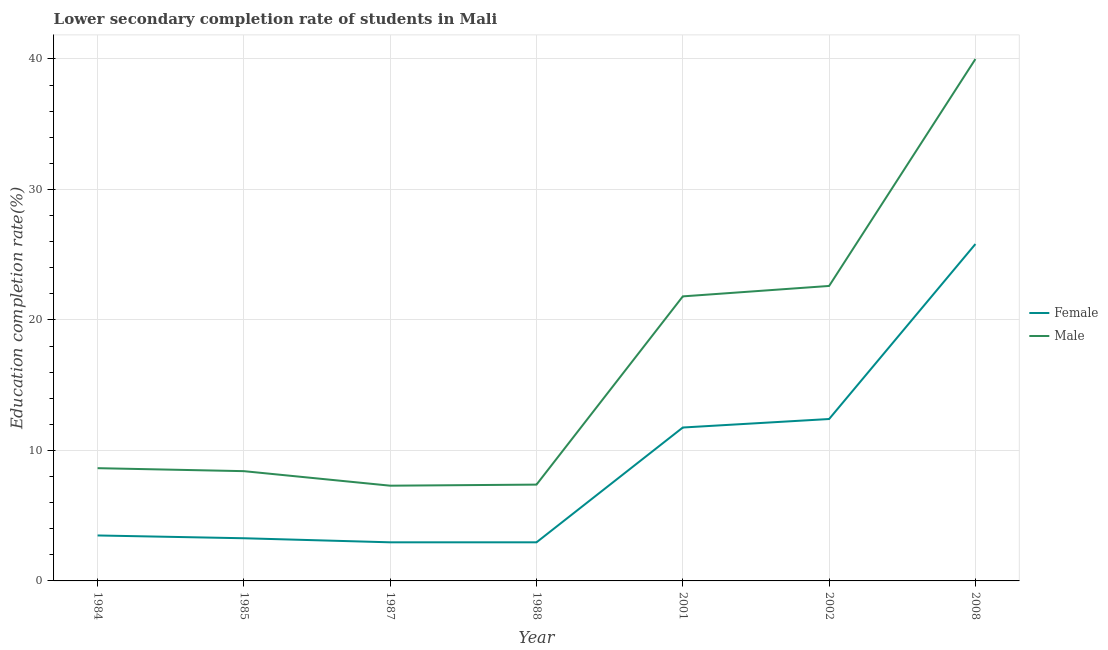Does the line corresponding to education completion rate of female students intersect with the line corresponding to education completion rate of male students?
Make the answer very short. No. Is the number of lines equal to the number of legend labels?
Your answer should be very brief. Yes. What is the education completion rate of male students in 1984?
Give a very brief answer. 8.64. Across all years, what is the maximum education completion rate of female students?
Your answer should be very brief. 25.82. Across all years, what is the minimum education completion rate of male students?
Provide a short and direct response. 7.3. What is the total education completion rate of male students in the graph?
Provide a short and direct response. 116.13. What is the difference between the education completion rate of female students in 1987 and that in 2002?
Your answer should be compact. -9.45. What is the difference between the education completion rate of male students in 1988 and the education completion rate of female students in 1984?
Ensure brevity in your answer.  3.9. What is the average education completion rate of female students per year?
Your answer should be very brief. 8.95. In the year 1985, what is the difference between the education completion rate of male students and education completion rate of female students?
Your response must be concise. 5.14. In how many years, is the education completion rate of female students greater than 16 %?
Provide a succinct answer. 1. What is the ratio of the education completion rate of female students in 1984 to that in 2001?
Offer a very short reply. 0.3. Is the education completion rate of male students in 1984 less than that in 1987?
Provide a short and direct response. No. What is the difference between the highest and the second highest education completion rate of male students?
Ensure brevity in your answer.  17.39. What is the difference between the highest and the lowest education completion rate of female students?
Provide a succinct answer. 22.86. Does the education completion rate of male students monotonically increase over the years?
Your response must be concise. No. Are the values on the major ticks of Y-axis written in scientific E-notation?
Provide a succinct answer. No. Where does the legend appear in the graph?
Offer a very short reply. Center right. What is the title of the graph?
Give a very brief answer. Lower secondary completion rate of students in Mali. Does "Tetanus" appear as one of the legend labels in the graph?
Keep it short and to the point. No. What is the label or title of the X-axis?
Your response must be concise. Year. What is the label or title of the Y-axis?
Your answer should be compact. Education completion rate(%). What is the Education completion rate(%) in Female in 1984?
Keep it short and to the point. 3.48. What is the Education completion rate(%) of Male in 1984?
Give a very brief answer. 8.64. What is the Education completion rate(%) of Female in 1985?
Offer a terse response. 3.27. What is the Education completion rate(%) of Male in 1985?
Your response must be concise. 8.41. What is the Education completion rate(%) of Female in 1987?
Give a very brief answer. 2.96. What is the Education completion rate(%) of Male in 1987?
Offer a very short reply. 7.3. What is the Education completion rate(%) of Female in 1988?
Your response must be concise. 2.96. What is the Education completion rate(%) of Male in 1988?
Keep it short and to the point. 7.38. What is the Education completion rate(%) in Female in 2001?
Your answer should be very brief. 11.76. What is the Education completion rate(%) of Male in 2001?
Ensure brevity in your answer.  21.81. What is the Education completion rate(%) in Female in 2002?
Offer a terse response. 12.41. What is the Education completion rate(%) of Male in 2002?
Give a very brief answer. 22.6. What is the Education completion rate(%) in Female in 2008?
Provide a succinct answer. 25.82. What is the Education completion rate(%) in Male in 2008?
Your answer should be very brief. 39.99. Across all years, what is the maximum Education completion rate(%) of Female?
Make the answer very short. 25.82. Across all years, what is the maximum Education completion rate(%) of Male?
Make the answer very short. 39.99. Across all years, what is the minimum Education completion rate(%) of Female?
Offer a terse response. 2.96. Across all years, what is the minimum Education completion rate(%) in Male?
Ensure brevity in your answer.  7.3. What is the total Education completion rate(%) of Female in the graph?
Provide a succinct answer. 62.65. What is the total Education completion rate(%) of Male in the graph?
Your response must be concise. 116.13. What is the difference between the Education completion rate(%) of Female in 1984 and that in 1985?
Keep it short and to the point. 0.21. What is the difference between the Education completion rate(%) in Male in 1984 and that in 1985?
Make the answer very short. 0.23. What is the difference between the Education completion rate(%) in Female in 1984 and that in 1987?
Keep it short and to the point. 0.53. What is the difference between the Education completion rate(%) of Male in 1984 and that in 1987?
Keep it short and to the point. 1.34. What is the difference between the Education completion rate(%) in Female in 1984 and that in 1988?
Keep it short and to the point. 0.53. What is the difference between the Education completion rate(%) in Male in 1984 and that in 1988?
Your answer should be very brief. 1.26. What is the difference between the Education completion rate(%) of Female in 1984 and that in 2001?
Make the answer very short. -8.27. What is the difference between the Education completion rate(%) of Male in 1984 and that in 2001?
Give a very brief answer. -13.17. What is the difference between the Education completion rate(%) of Female in 1984 and that in 2002?
Provide a short and direct response. -8.92. What is the difference between the Education completion rate(%) of Male in 1984 and that in 2002?
Give a very brief answer. -13.96. What is the difference between the Education completion rate(%) of Female in 1984 and that in 2008?
Your answer should be compact. -22.33. What is the difference between the Education completion rate(%) of Male in 1984 and that in 2008?
Give a very brief answer. -31.35. What is the difference between the Education completion rate(%) of Female in 1985 and that in 1987?
Offer a terse response. 0.31. What is the difference between the Education completion rate(%) in Male in 1985 and that in 1987?
Your answer should be compact. 1.11. What is the difference between the Education completion rate(%) of Female in 1985 and that in 1988?
Your answer should be very brief. 0.31. What is the difference between the Education completion rate(%) of Male in 1985 and that in 1988?
Keep it short and to the point. 1.03. What is the difference between the Education completion rate(%) of Female in 1985 and that in 2001?
Keep it short and to the point. -8.49. What is the difference between the Education completion rate(%) in Male in 1985 and that in 2001?
Keep it short and to the point. -13.39. What is the difference between the Education completion rate(%) of Female in 1985 and that in 2002?
Give a very brief answer. -9.14. What is the difference between the Education completion rate(%) of Male in 1985 and that in 2002?
Your response must be concise. -14.19. What is the difference between the Education completion rate(%) in Female in 1985 and that in 2008?
Provide a succinct answer. -22.55. What is the difference between the Education completion rate(%) in Male in 1985 and that in 2008?
Keep it short and to the point. -31.58. What is the difference between the Education completion rate(%) in Female in 1987 and that in 1988?
Offer a terse response. 0. What is the difference between the Education completion rate(%) in Male in 1987 and that in 1988?
Offer a very short reply. -0.08. What is the difference between the Education completion rate(%) in Female in 1987 and that in 2001?
Offer a terse response. -8.8. What is the difference between the Education completion rate(%) of Male in 1987 and that in 2001?
Ensure brevity in your answer.  -14.51. What is the difference between the Education completion rate(%) of Female in 1987 and that in 2002?
Make the answer very short. -9.45. What is the difference between the Education completion rate(%) of Male in 1987 and that in 2002?
Your response must be concise. -15.31. What is the difference between the Education completion rate(%) in Female in 1987 and that in 2008?
Provide a short and direct response. -22.86. What is the difference between the Education completion rate(%) in Male in 1987 and that in 2008?
Offer a terse response. -32.69. What is the difference between the Education completion rate(%) in Female in 1988 and that in 2001?
Keep it short and to the point. -8.8. What is the difference between the Education completion rate(%) of Male in 1988 and that in 2001?
Give a very brief answer. -14.42. What is the difference between the Education completion rate(%) in Female in 1988 and that in 2002?
Offer a very short reply. -9.45. What is the difference between the Education completion rate(%) of Male in 1988 and that in 2002?
Ensure brevity in your answer.  -15.22. What is the difference between the Education completion rate(%) of Female in 1988 and that in 2008?
Offer a very short reply. -22.86. What is the difference between the Education completion rate(%) in Male in 1988 and that in 2008?
Your response must be concise. -32.61. What is the difference between the Education completion rate(%) in Female in 2001 and that in 2002?
Provide a succinct answer. -0.65. What is the difference between the Education completion rate(%) in Male in 2001 and that in 2002?
Provide a succinct answer. -0.8. What is the difference between the Education completion rate(%) of Female in 2001 and that in 2008?
Provide a short and direct response. -14.06. What is the difference between the Education completion rate(%) of Male in 2001 and that in 2008?
Provide a short and direct response. -18.19. What is the difference between the Education completion rate(%) in Female in 2002 and that in 2008?
Your answer should be very brief. -13.41. What is the difference between the Education completion rate(%) in Male in 2002 and that in 2008?
Your answer should be compact. -17.39. What is the difference between the Education completion rate(%) in Female in 1984 and the Education completion rate(%) in Male in 1985?
Make the answer very short. -4.93. What is the difference between the Education completion rate(%) in Female in 1984 and the Education completion rate(%) in Male in 1987?
Offer a very short reply. -3.81. What is the difference between the Education completion rate(%) of Female in 1984 and the Education completion rate(%) of Male in 1988?
Provide a short and direct response. -3.9. What is the difference between the Education completion rate(%) of Female in 1984 and the Education completion rate(%) of Male in 2001?
Offer a very short reply. -18.32. What is the difference between the Education completion rate(%) in Female in 1984 and the Education completion rate(%) in Male in 2002?
Your answer should be very brief. -19.12. What is the difference between the Education completion rate(%) in Female in 1984 and the Education completion rate(%) in Male in 2008?
Your answer should be compact. -36.51. What is the difference between the Education completion rate(%) of Female in 1985 and the Education completion rate(%) of Male in 1987?
Offer a very short reply. -4.03. What is the difference between the Education completion rate(%) in Female in 1985 and the Education completion rate(%) in Male in 1988?
Keep it short and to the point. -4.11. What is the difference between the Education completion rate(%) in Female in 1985 and the Education completion rate(%) in Male in 2001?
Your answer should be very brief. -18.53. What is the difference between the Education completion rate(%) in Female in 1985 and the Education completion rate(%) in Male in 2002?
Ensure brevity in your answer.  -19.33. What is the difference between the Education completion rate(%) in Female in 1985 and the Education completion rate(%) in Male in 2008?
Provide a short and direct response. -36.72. What is the difference between the Education completion rate(%) of Female in 1987 and the Education completion rate(%) of Male in 1988?
Provide a short and direct response. -4.42. What is the difference between the Education completion rate(%) of Female in 1987 and the Education completion rate(%) of Male in 2001?
Provide a succinct answer. -18.85. What is the difference between the Education completion rate(%) in Female in 1987 and the Education completion rate(%) in Male in 2002?
Ensure brevity in your answer.  -19.65. What is the difference between the Education completion rate(%) of Female in 1987 and the Education completion rate(%) of Male in 2008?
Your answer should be compact. -37.03. What is the difference between the Education completion rate(%) in Female in 1988 and the Education completion rate(%) in Male in 2001?
Your answer should be very brief. -18.85. What is the difference between the Education completion rate(%) in Female in 1988 and the Education completion rate(%) in Male in 2002?
Make the answer very short. -19.65. What is the difference between the Education completion rate(%) of Female in 1988 and the Education completion rate(%) of Male in 2008?
Give a very brief answer. -37.03. What is the difference between the Education completion rate(%) in Female in 2001 and the Education completion rate(%) in Male in 2002?
Offer a very short reply. -10.85. What is the difference between the Education completion rate(%) of Female in 2001 and the Education completion rate(%) of Male in 2008?
Your answer should be compact. -28.24. What is the difference between the Education completion rate(%) in Female in 2002 and the Education completion rate(%) in Male in 2008?
Provide a succinct answer. -27.59. What is the average Education completion rate(%) in Female per year?
Offer a terse response. 8.95. What is the average Education completion rate(%) of Male per year?
Give a very brief answer. 16.59. In the year 1984, what is the difference between the Education completion rate(%) in Female and Education completion rate(%) in Male?
Make the answer very short. -5.16. In the year 1985, what is the difference between the Education completion rate(%) in Female and Education completion rate(%) in Male?
Provide a succinct answer. -5.14. In the year 1987, what is the difference between the Education completion rate(%) in Female and Education completion rate(%) in Male?
Your answer should be compact. -4.34. In the year 1988, what is the difference between the Education completion rate(%) in Female and Education completion rate(%) in Male?
Provide a succinct answer. -4.42. In the year 2001, what is the difference between the Education completion rate(%) of Female and Education completion rate(%) of Male?
Provide a short and direct response. -10.05. In the year 2002, what is the difference between the Education completion rate(%) of Female and Education completion rate(%) of Male?
Ensure brevity in your answer.  -10.2. In the year 2008, what is the difference between the Education completion rate(%) in Female and Education completion rate(%) in Male?
Offer a terse response. -14.18. What is the ratio of the Education completion rate(%) in Female in 1984 to that in 1985?
Ensure brevity in your answer.  1.07. What is the ratio of the Education completion rate(%) in Male in 1984 to that in 1985?
Ensure brevity in your answer.  1.03. What is the ratio of the Education completion rate(%) in Female in 1984 to that in 1987?
Provide a succinct answer. 1.18. What is the ratio of the Education completion rate(%) of Male in 1984 to that in 1987?
Offer a very short reply. 1.18. What is the ratio of the Education completion rate(%) in Female in 1984 to that in 1988?
Provide a short and direct response. 1.18. What is the ratio of the Education completion rate(%) of Male in 1984 to that in 1988?
Give a very brief answer. 1.17. What is the ratio of the Education completion rate(%) in Female in 1984 to that in 2001?
Your answer should be compact. 0.3. What is the ratio of the Education completion rate(%) in Male in 1984 to that in 2001?
Offer a terse response. 0.4. What is the ratio of the Education completion rate(%) in Female in 1984 to that in 2002?
Offer a very short reply. 0.28. What is the ratio of the Education completion rate(%) in Male in 1984 to that in 2002?
Give a very brief answer. 0.38. What is the ratio of the Education completion rate(%) of Female in 1984 to that in 2008?
Ensure brevity in your answer.  0.13. What is the ratio of the Education completion rate(%) in Male in 1984 to that in 2008?
Keep it short and to the point. 0.22. What is the ratio of the Education completion rate(%) in Female in 1985 to that in 1987?
Give a very brief answer. 1.11. What is the ratio of the Education completion rate(%) of Male in 1985 to that in 1987?
Provide a succinct answer. 1.15. What is the ratio of the Education completion rate(%) in Female in 1985 to that in 1988?
Provide a succinct answer. 1.11. What is the ratio of the Education completion rate(%) of Male in 1985 to that in 1988?
Offer a terse response. 1.14. What is the ratio of the Education completion rate(%) of Female in 1985 to that in 2001?
Your answer should be compact. 0.28. What is the ratio of the Education completion rate(%) of Male in 1985 to that in 2001?
Keep it short and to the point. 0.39. What is the ratio of the Education completion rate(%) of Female in 1985 to that in 2002?
Offer a very short reply. 0.26. What is the ratio of the Education completion rate(%) of Male in 1985 to that in 2002?
Your response must be concise. 0.37. What is the ratio of the Education completion rate(%) of Female in 1985 to that in 2008?
Provide a short and direct response. 0.13. What is the ratio of the Education completion rate(%) of Male in 1985 to that in 2008?
Your response must be concise. 0.21. What is the ratio of the Education completion rate(%) in Male in 1987 to that in 1988?
Offer a very short reply. 0.99. What is the ratio of the Education completion rate(%) in Female in 1987 to that in 2001?
Your response must be concise. 0.25. What is the ratio of the Education completion rate(%) in Male in 1987 to that in 2001?
Provide a succinct answer. 0.33. What is the ratio of the Education completion rate(%) in Female in 1987 to that in 2002?
Your answer should be very brief. 0.24. What is the ratio of the Education completion rate(%) of Male in 1987 to that in 2002?
Give a very brief answer. 0.32. What is the ratio of the Education completion rate(%) in Female in 1987 to that in 2008?
Your response must be concise. 0.11. What is the ratio of the Education completion rate(%) of Male in 1987 to that in 2008?
Offer a terse response. 0.18. What is the ratio of the Education completion rate(%) of Female in 1988 to that in 2001?
Give a very brief answer. 0.25. What is the ratio of the Education completion rate(%) of Male in 1988 to that in 2001?
Give a very brief answer. 0.34. What is the ratio of the Education completion rate(%) of Female in 1988 to that in 2002?
Provide a succinct answer. 0.24. What is the ratio of the Education completion rate(%) of Male in 1988 to that in 2002?
Offer a very short reply. 0.33. What is the ratio of the Education completion rate(%) of Female in 1988 to that in 2008?
Keep it short and to the point. 0.11. What is the ratio of the Education completion rate(%) in Male in 1988 to that in 2008?
Keep it short and to the point. 0.18. What is the ratio of the Education completion rate(%) of Female in 2001 to that in 2002?
Provide a short and direct response. 0.95. What is the ratio of the Education completion rate(%) in Male in 2001 to that in 2002?
Offer a terse response. 0.96. What is the ratio of the Education completion rate(%) in Female in 2001 to that in 2008?
Your answer should be very brief. 0.46. What is the ratio of the Education completion rate(%) of Male in 2001 to that in 2008?
Keep it short and to the point. 0.55. What is the ratio of the Education completion rate(%) in Female in 2002 to that in 2008?
Provide a succinct answer. 0.48. What is the ratio of the Education completion rate(%) of Male in 2002 to that in 2008?
Your answer should be compact. 0.57. What is the difference between the highest and the second highest Education completion rate(%) in Female?
Provide a succinct answer. 13.41. What is the difference between the highest and the second highest Education completion rate(%) of Male?
Keep it short and to the point. 17.39. What is the difference between the highest and the lowest Education completion rate(%) of Female?
Offer a very short reply. 22.86. What is the difference between the highest and the lowest Education completion rate(%) in Male?
Ensure brevity in your answer.  32.69. 